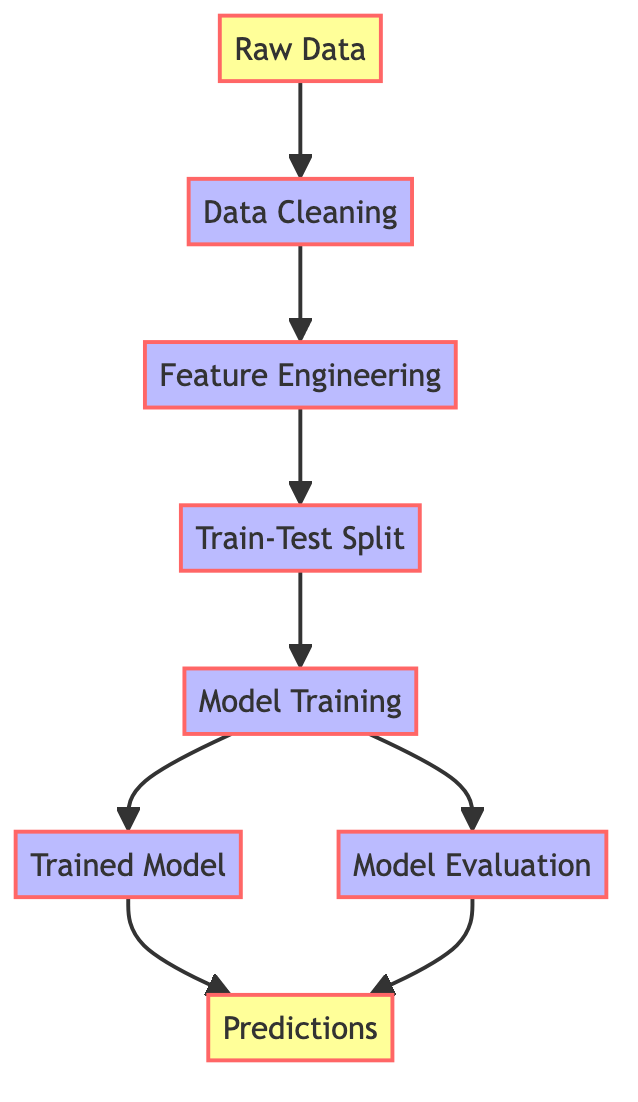What is the first step in the pipeline? The first step in the pipeline is represented by the node labeled "Raw Data." This is the starting point before any processing occurs.
Answer: Raw Data How many nodes are in the diagram? To determine the number of nodes, we count each unique entity in the node list provided in the data: Raw Data, Data Cleaning, Feature Engineering, Train-Test Split, Model Training, Model Evaluation, Trained Model, Predictions. This totals to eight distinct nodes.
Answer: 8 What is the last step after model evaluation? After the "Model Evaluation" step, both "Predictions" are derived. Following the directed edges, "Model Evaluation" directly points to "Predictions." Therefore, the last action corresponds to making predictions based on the evaluation of the model.
Answer: Predictions What processes come after data cleaning? The diagram indicates that following "Data Cleaning," the next step is "Feature Engineering." From the directed edge, we can see this sequence clearly outlined.
Answer: Feature Engineering Which nodes have edges leading to the predictions node? The "Predictions" node has incoming edges from both "Trained Model" and "Model Evaluation." This indicates that predictions can be generated directly from either of the paths, highlighting their interdependency in the pipeline.
Answer: Trained Model, Model Evaluation How many edges are there in total? We count the directed connections (edges) as listed in the data: from "Raw Data" to "Data Cleaning," then "Data Cleaning" to "Feature Engineering," and so on. There are a total of seven edges connecting the nodes.
Answer: 7 What type of processes are represented in the diagram? The processes represented in the diagram are denoted by nodes related to data handling steps, including Data Cleaning, Feature Engineering, Train-Test Split, Model Training, and Model Evaluation, indicating they follow a systematic flow for machine learning tasks.
Answer: Data handling steps What is the relationship between trained model and predictions? The "Trained Model" node has a direct edge to "Predictions," which signifies that once the model is trained, it can be utilized to generate predictions. This relationship is critical in the machine learning pipeline.
Answer: Direct edge relationship 